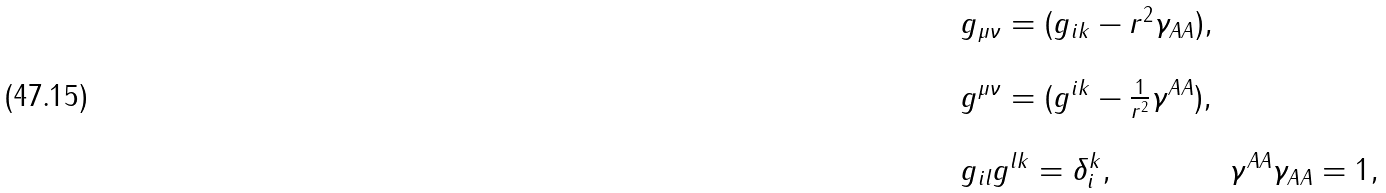<formula> <loc_0><loc_0><loc_500><loc_500>\begin{array} { l c } g _ { \mu \nu } = ( g _ { i k } - r ^ { 2 } \gamma _ { A A } ) , \\ \\ g ^ { \mu \nu } = ( g ^ { i k } - \frac { 1 } { r ^ { 2 } } \gamma ^ { A A } ) , \\ \\ g _ { i l } g ^ { l k } = \delta ^ { k } _ { i } , & \gamma ^ { A A } \gamma _ { A A } = 1 , \end{array}</formula> 